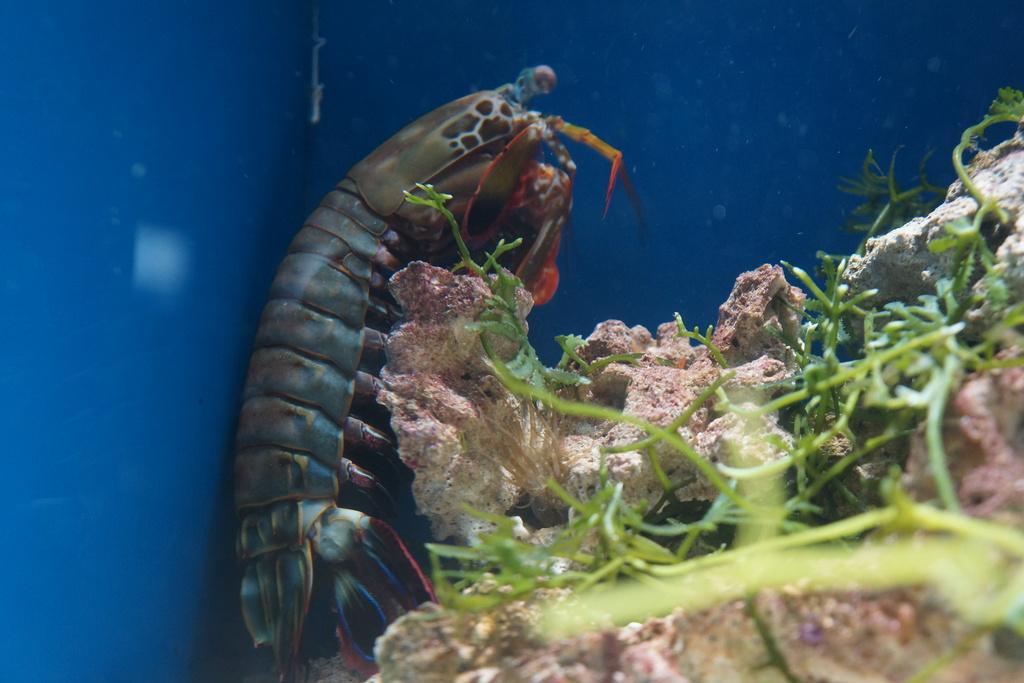Can you describe this image briefly? In this image we can see shrimp and plants. 